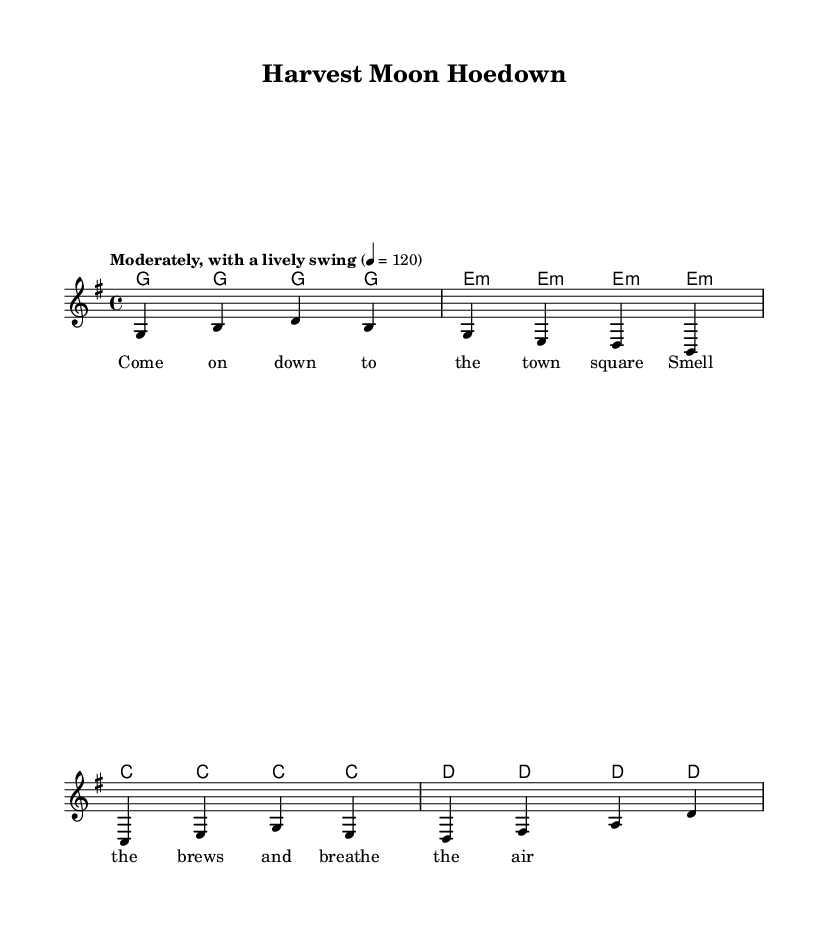What is the key signature of this music? The key signature is G major, indicated by one sharp (F#) on the staff.
Answer: G major What is the time signature of this piece? The time signature is located at the beginning of the staff, showing a 4 over 4, which means there are four beats in a measure.
Answer: 4/4 What is the tempo marking for this piece? The tempo is specified at the beginning, stating "Moderately, with a lively swing," followed by a metronome marking of quarter note equals 120.
Answer: Moderately, with a lively swing How many bars are in the melody section? The melody section is made up of four measures, which can be counted from the beginning to the end of that part.
Answer: 4 What is the tonic chord used in the harmonies? The tonic chord is the first chord in the harmony sequence, which is the G major chord since it’s based on the key signature of G major.
Answer: G major What is the theme of the lyrics? The lyrics describe a gathering at the town square, highlighting the smell of brews and the experience of community.
Answer: Community gathering How does the structure of this piece reflect folk music? The song features a simple melody, repetitive harmonic structure, and lyrics that celebrate local culture and gatherings, typical characteristics of folk music.
Answer: Simple melody and local themes 